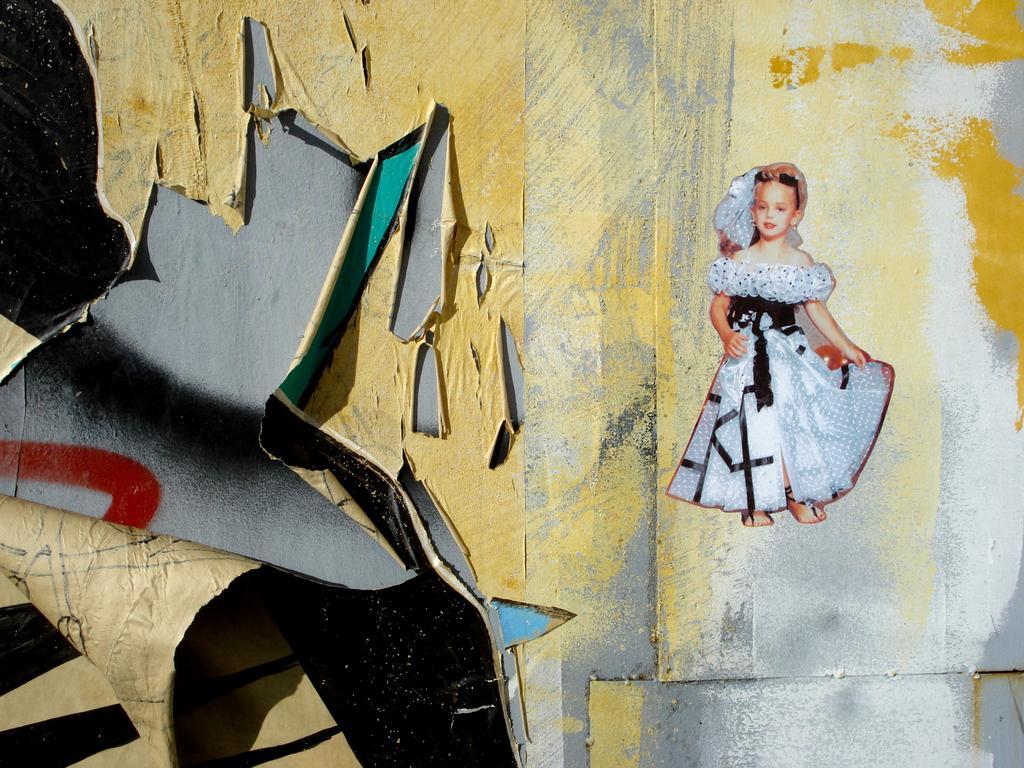Could you give a brief overview of what you see in this image? In this picture we can see a wallpaper sticker of the small girl wearing white dress. On the left corner we can see the tone wallpaper. 